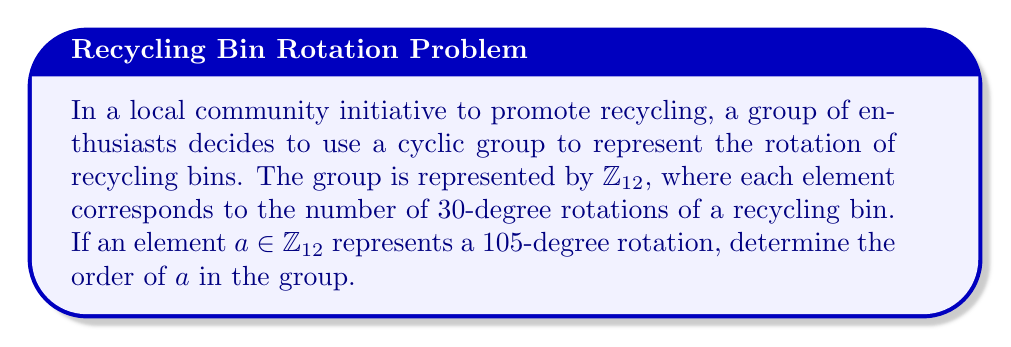Show me your answer to this math problem. Let's approach this step-by-step:

1) First, we need to understand what the element $a$ represents in $\mathbb{Z}_{12}$:
   - 105 degrees = 3.5 * 30 degrees
   - This means $a = 3.5$ (mod 12), which is equivalent to $a = 3$ (mod 12)

2) Now, we need to find the order of $a = 3$ in $\mathbb{Z}_{12}$. The order of an element is the smallest positive integer $n$ such that $a^n \equiv 1$ (mod 12).

3) Let's compute the powers of $a$:
   $a^1 = 3$ (mod 12)
   $a^2 = 3 * 3 = 9$ (mod 12)
   $a^3 = 3 * 9 = 27 \equiv 3$ (mod 12)
   $a^4 = 3 * 3 = 9$ (mod 12)

4) We see that the pattern repeats after $a^3$. This means that $a^4 = a^1$, $a^5 = a^2$, and so on.

5) The smallest positive integer $n$ such that $a^n \equiv 1$ (mod 12) is 4, because:
   $a^4 = 3^4 = 81 \equiv 9$ (mod 12)
   $a^8 = 9^2 = 81 \equiv 9$ (mod 12)
   $a^{12} = 9^3 = 729 \equiv 1$ (mod 12)

Therefore, the order of $a$ in $\mathbb{Z}_{12}$ is 4.
Answer: The order of $a$ in $\mathbb{Z}_{12}$ is 4. 